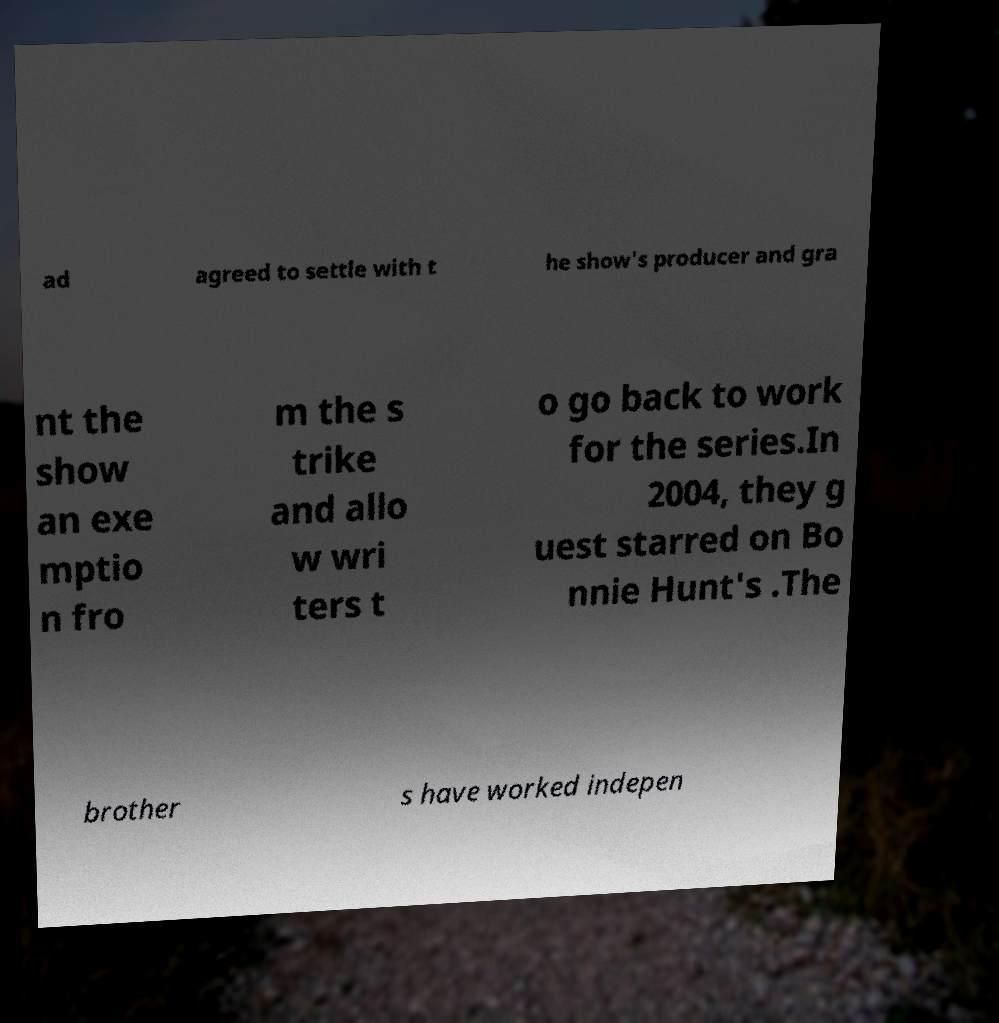Can you accurately transcribe the text from the provided image for me? ad agreed to settle with t he show's producer and gra nt the show an exe mptio n fro m the s trike and allo w wri ters t o go back to work for the series.In 2004, they g uest starred on Bo nnie Hunt's .The brother s have worked indepen 